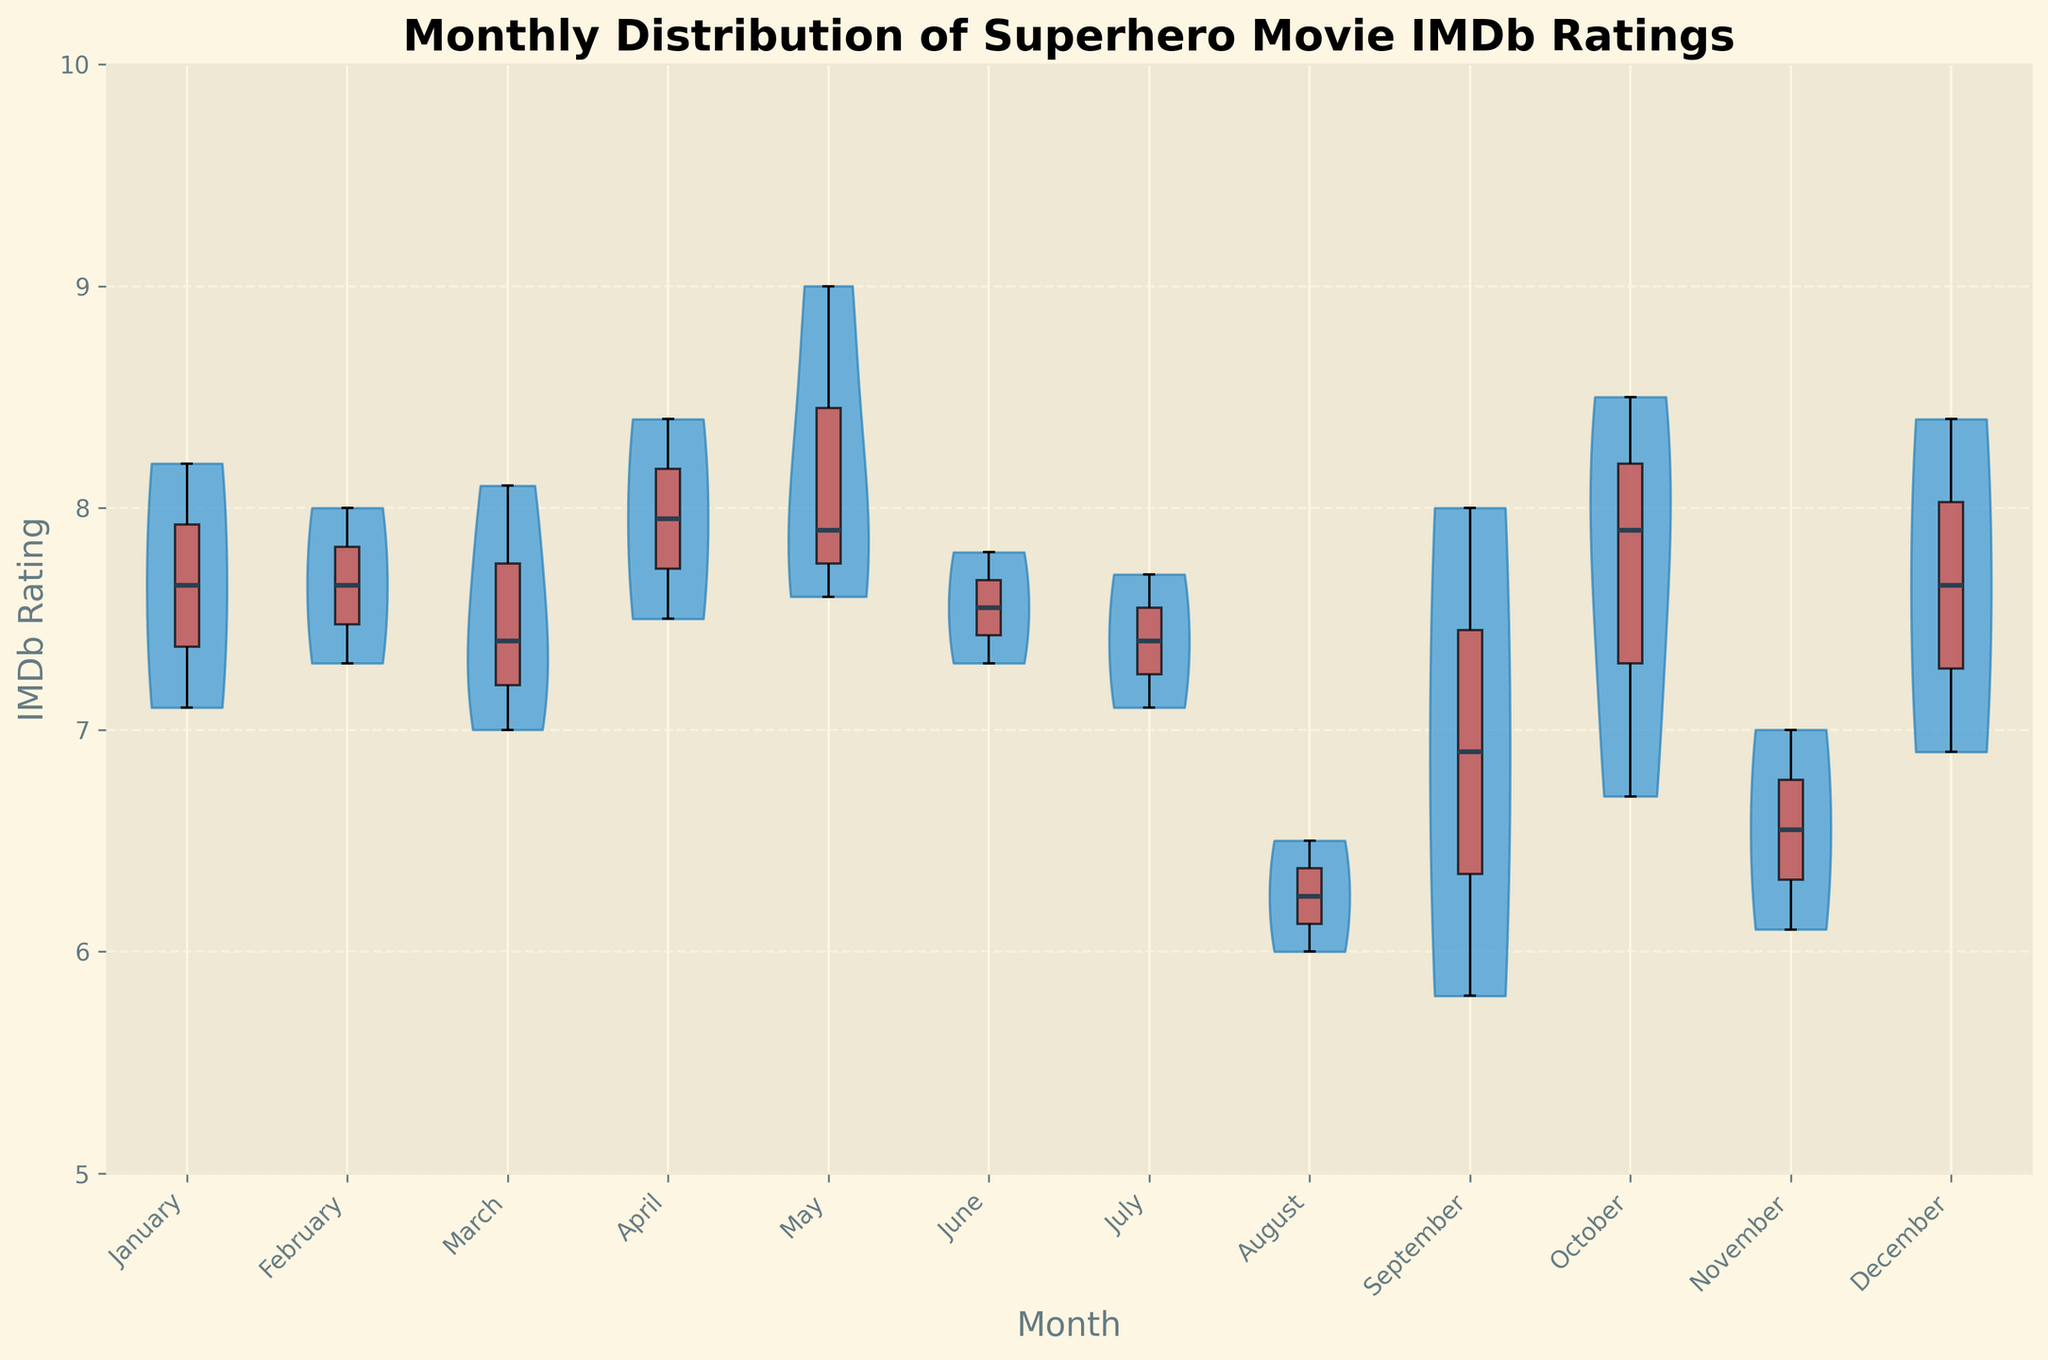What is the title of the figure? The title is usually displayed at the top of the figure. In this case, it reads "Monthly Distribution of Superhero Movie IMDb Ratings."
Answer: Monthly Distribution of Superhero Movie IMDb Ratings What are the months with the highest median IMDb rating? Look for the box plots in each month’s violin chart and identify the months where the horizontal line inside the box (indicating the median) is highest.
Answer: May, April Which month has the lowest spread of IMDb ratings? Examine the widths and shapes of the violin plots for each month. The month with the violin plot that has the narrowest range from top to bottom indicates the lowest spread.
Answer: May What is the average median IMDb rating across all months? Identify the median value for each month’s box plot, sum these median values, and then divide by the number of months. Step-by-step: Find medians (e.g., April: 8.4, May: 7.8, etc.), calculate the sum, and then divide by 12 months.
Answer: (8.2 + 7.65 + 7.4 + 7.95 + 8.45 + 7.55 + 6.25 + 6.60 + 6.85 + 7.0 + 6.55 + 7.65) / 12 = 7.47 Which month has the highest maximum IMDb rating, and what is that rating? Check the top ends of the whiskers in the box plots to find the month with the highest value.
Answer: May, 9.0 How does January's median IMDb rating compare to the overall average median rating? First, find January’s median from its box plot. Then, compare this value with the previously calculated overall average median rating.
Answer: January (8.2) is higher than overall average median (7.47) Which months have bimodal distributions in their rating data? Bimodal distributions show two peaks within the violin plot. Look for violin plots with two distinct bulges rather than a single peak.
Answer: October Are there any months where the rating distribution is skewed lower? Identify violin plots where the bulk of the data is at the lower end of the range (left side tapering off).
Answer: August In which month is the middle 50% of data (between Q1 and Q3) the widest? Examine the boxes in each box plot and find which has the longest vertical length.
Answer: July What is the range of IMDb ratings in June? Determine the minimum and maximum values indicated by the whiskers or edges of the violin plot in June. Calculate the difference between these values.
Answer: 7.8 - 6.7 = 1.1 